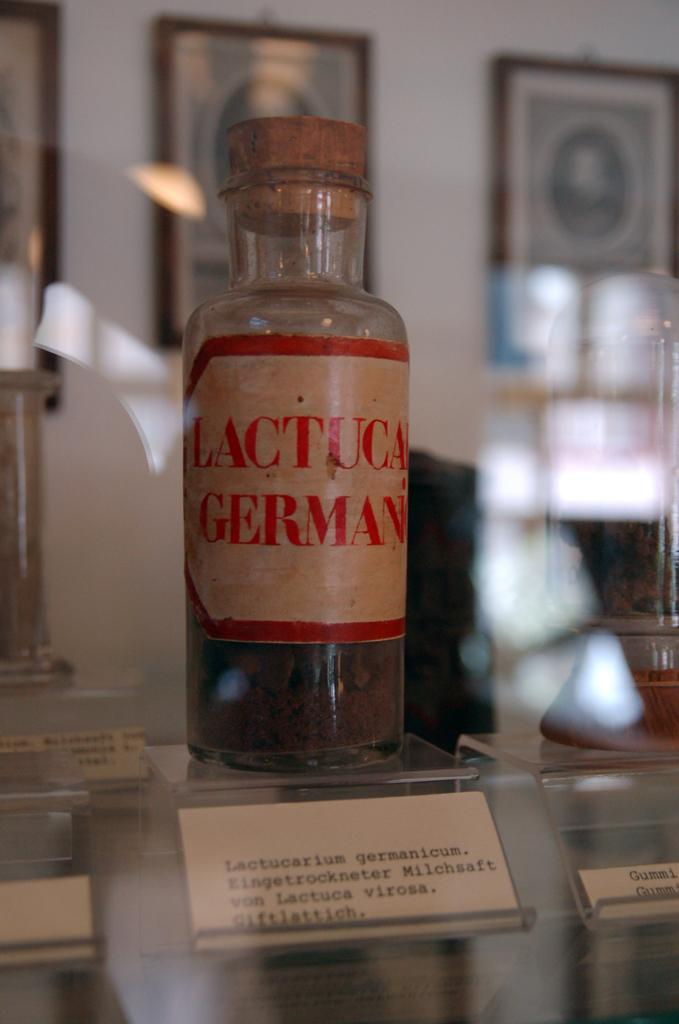<image>
Describe the image concisely. A glass bottle of Lactuca German is on display with a small card describing it in front 